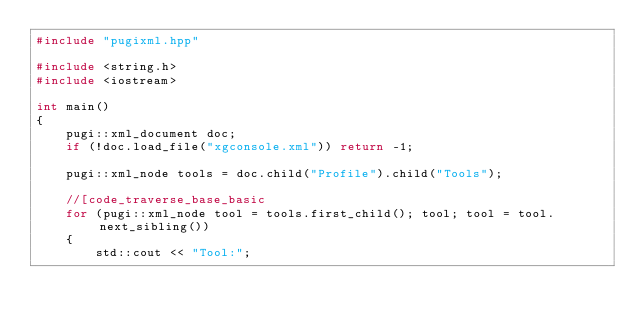<code> <loc_0><loc_0><loc_500><loc_500><_C++_>#include "pugixml.hpp"

#include <string.h>
#include <iostream>

int main()
{
    pugi::xml_document doc;
    if (!doc.load_file("xgconsole.xml")) return -1;

    pugi::xml_node tools = doc.child("Profile").child("Tools");

    //[code_traverse_base_basic
    for (pugi::xml_node tool = tools.first_child(); tool; tool = tool.next_sibling())
    {
        std::cout << "Tool:";
</code> 